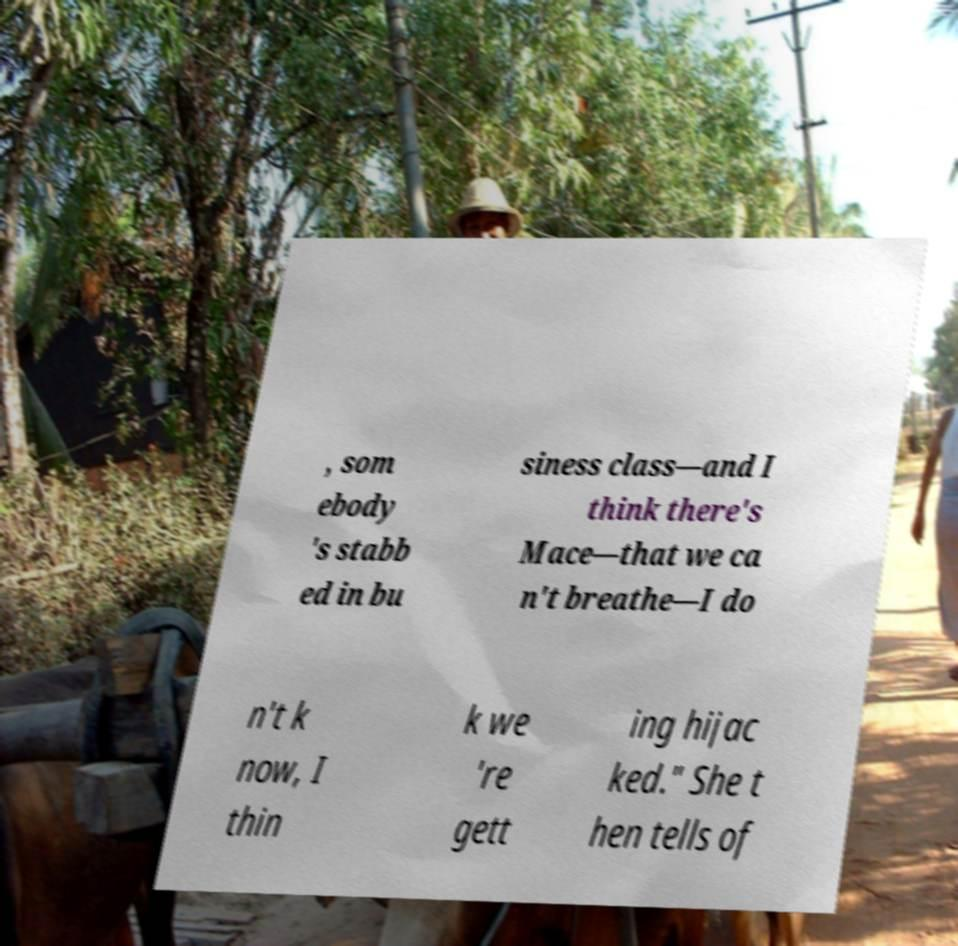I need the written content from this picture converted into text. Can you do that? , som ebody 's stabb ed in bu siness class—and I think there's Mace—that we ca n't breathe—I do n't k now, I thin k we 're gett ing hijac ked." She t hen tells of 